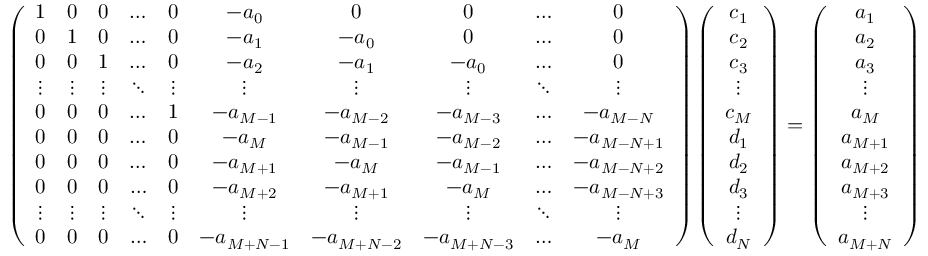Convert formula to latex. <formula><loc_0><loc_0><loc_500><loc_500>\begin{array} { r } { \left ( \begin{array} { c c c c c c c c c c } { 1 } & { 0 } & { 0 } & { \dots } & { 0 } & { - a _ { 0 } } & { 0 } & { 0 } & { \dots } & { 0 } \\ { 0 } & { 1 } & { 0 } & { \dots } & { 0 } & { - a _ { 1 } } & { - a _ { 0 } } & { 0 } & { \dots } & { 0 } \\ { 0 } & { 0 } & { 1 } & { \dots } & { 0 } & { - a _ { 2 } } & { - a _ { 1 } } & { - a _ { 0 } } & { \dots } & { 0 } \\ { \vdots } & { \vdots } & { \vdots } & { \ddots } & { \vdots } & { \vdots } & { \vdots } & { \vdots } & { \ddots } & { \vdots } \\ { 0 } & { 0 } & { 0 } & { \dots } & { 1 } & { - a _ { M - 1 } } & { - a _ { M - 2 } } & { - a _ { M - 3 } } & { \dots } & { - a _ { M - N } } \\ { 0 } & { 0 } & { 0 } & { \dots } & { 0 } & { - a _ { M } } & { - a _ { M - 1 } } & { - a _ { M - 2 } } & { \dots } & { - a _ { M - N + 1 } } \\ { 0 } & { 0 } & { 0 } & { \dots } & { 0 } & { - a _ { M + 1 } } & { - a _ { M } } & { - a _ { M - 1 } } & { \dots } & { - a _ { M - N + 2 } } \\ { 0 } & { 0 } & { 0 } & { \dots } & { 0 } & { - a _ { M + 2 } } & { - a _ { M + 1 } } & { - a _ { M } } & { \dots } & { - a _ { M - N + 3 } } \\ { \vdots } & { \vdots } & { \vdots } & { \ddots } & { \vdots } & { \vdots } & { \vdots } & { \vdots } & { \ddots } & { \vdots } \\ { 0 } & { 0 } & { 0 } & { \dots } & { 0 } & { - a _ { M + N - 1 } } & { - a _ { M + N - 2 } } & { - a _ { M + N - 3 } } & { \dots } & { - a _ { M } } \end{array} \right ) \left ( \begin{array} { c } { c _ { 1 } } \\ { c _ { 2 } } \\ { c _ { 3 } } \\ { \vdots } \\ { c _ { M } } \\ { d _ { 1 } } \\ { d _ { 2 } } \\ { d _ { 3 } } \\ { \vdots } \\ { d _ { N } } \end{array} \right ) = \left ( \begin{array} { c } { a _ { 1 } } \\ { a _ { 2 } } \\ { a _ { 3 } } \\ { \vdots } \\ { a _ { M } } \\ { a _ { M + 1 } } \\ { a _ { M + 2 } } \\ { a _ { M + 3 } } \\ { \vdots } \\ { a _ { M + N } } \end{array} \right ) } \end{array}</formula> 